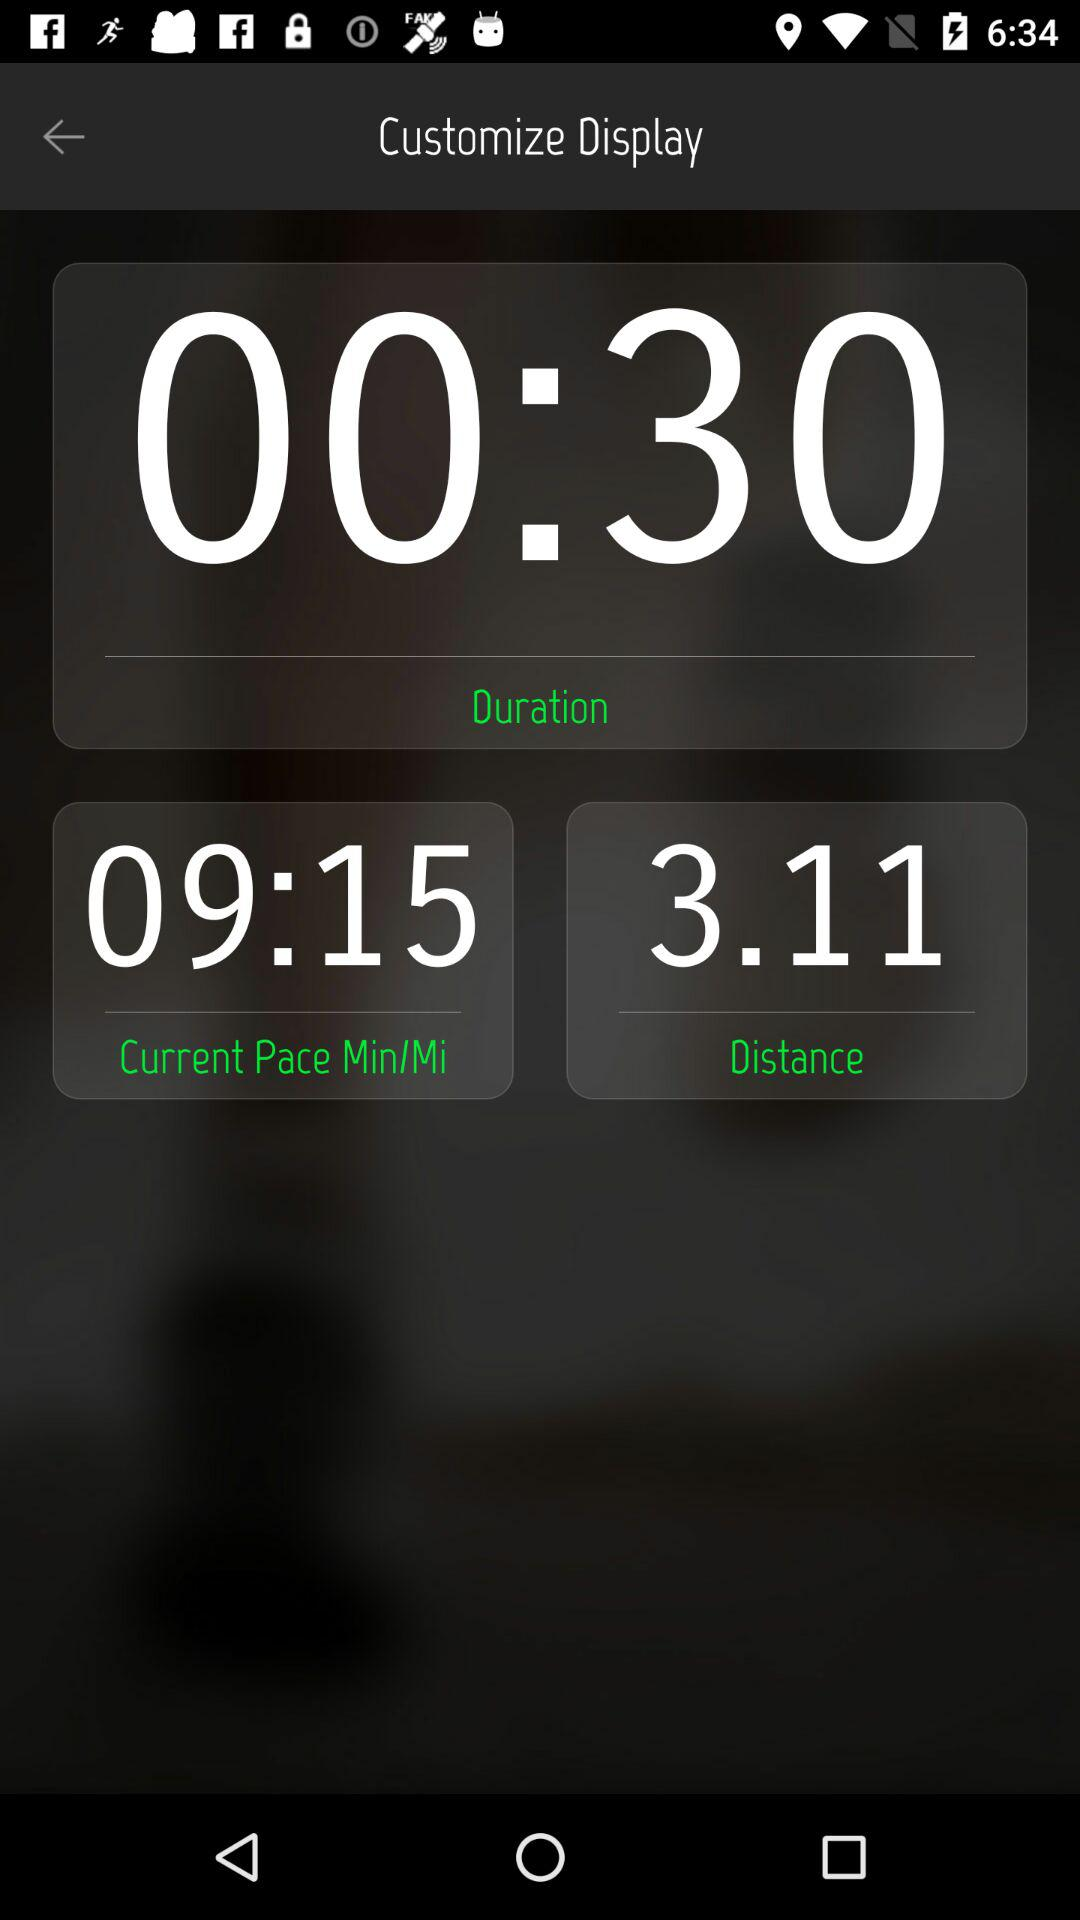What is the distance? The distance is 3.11. 